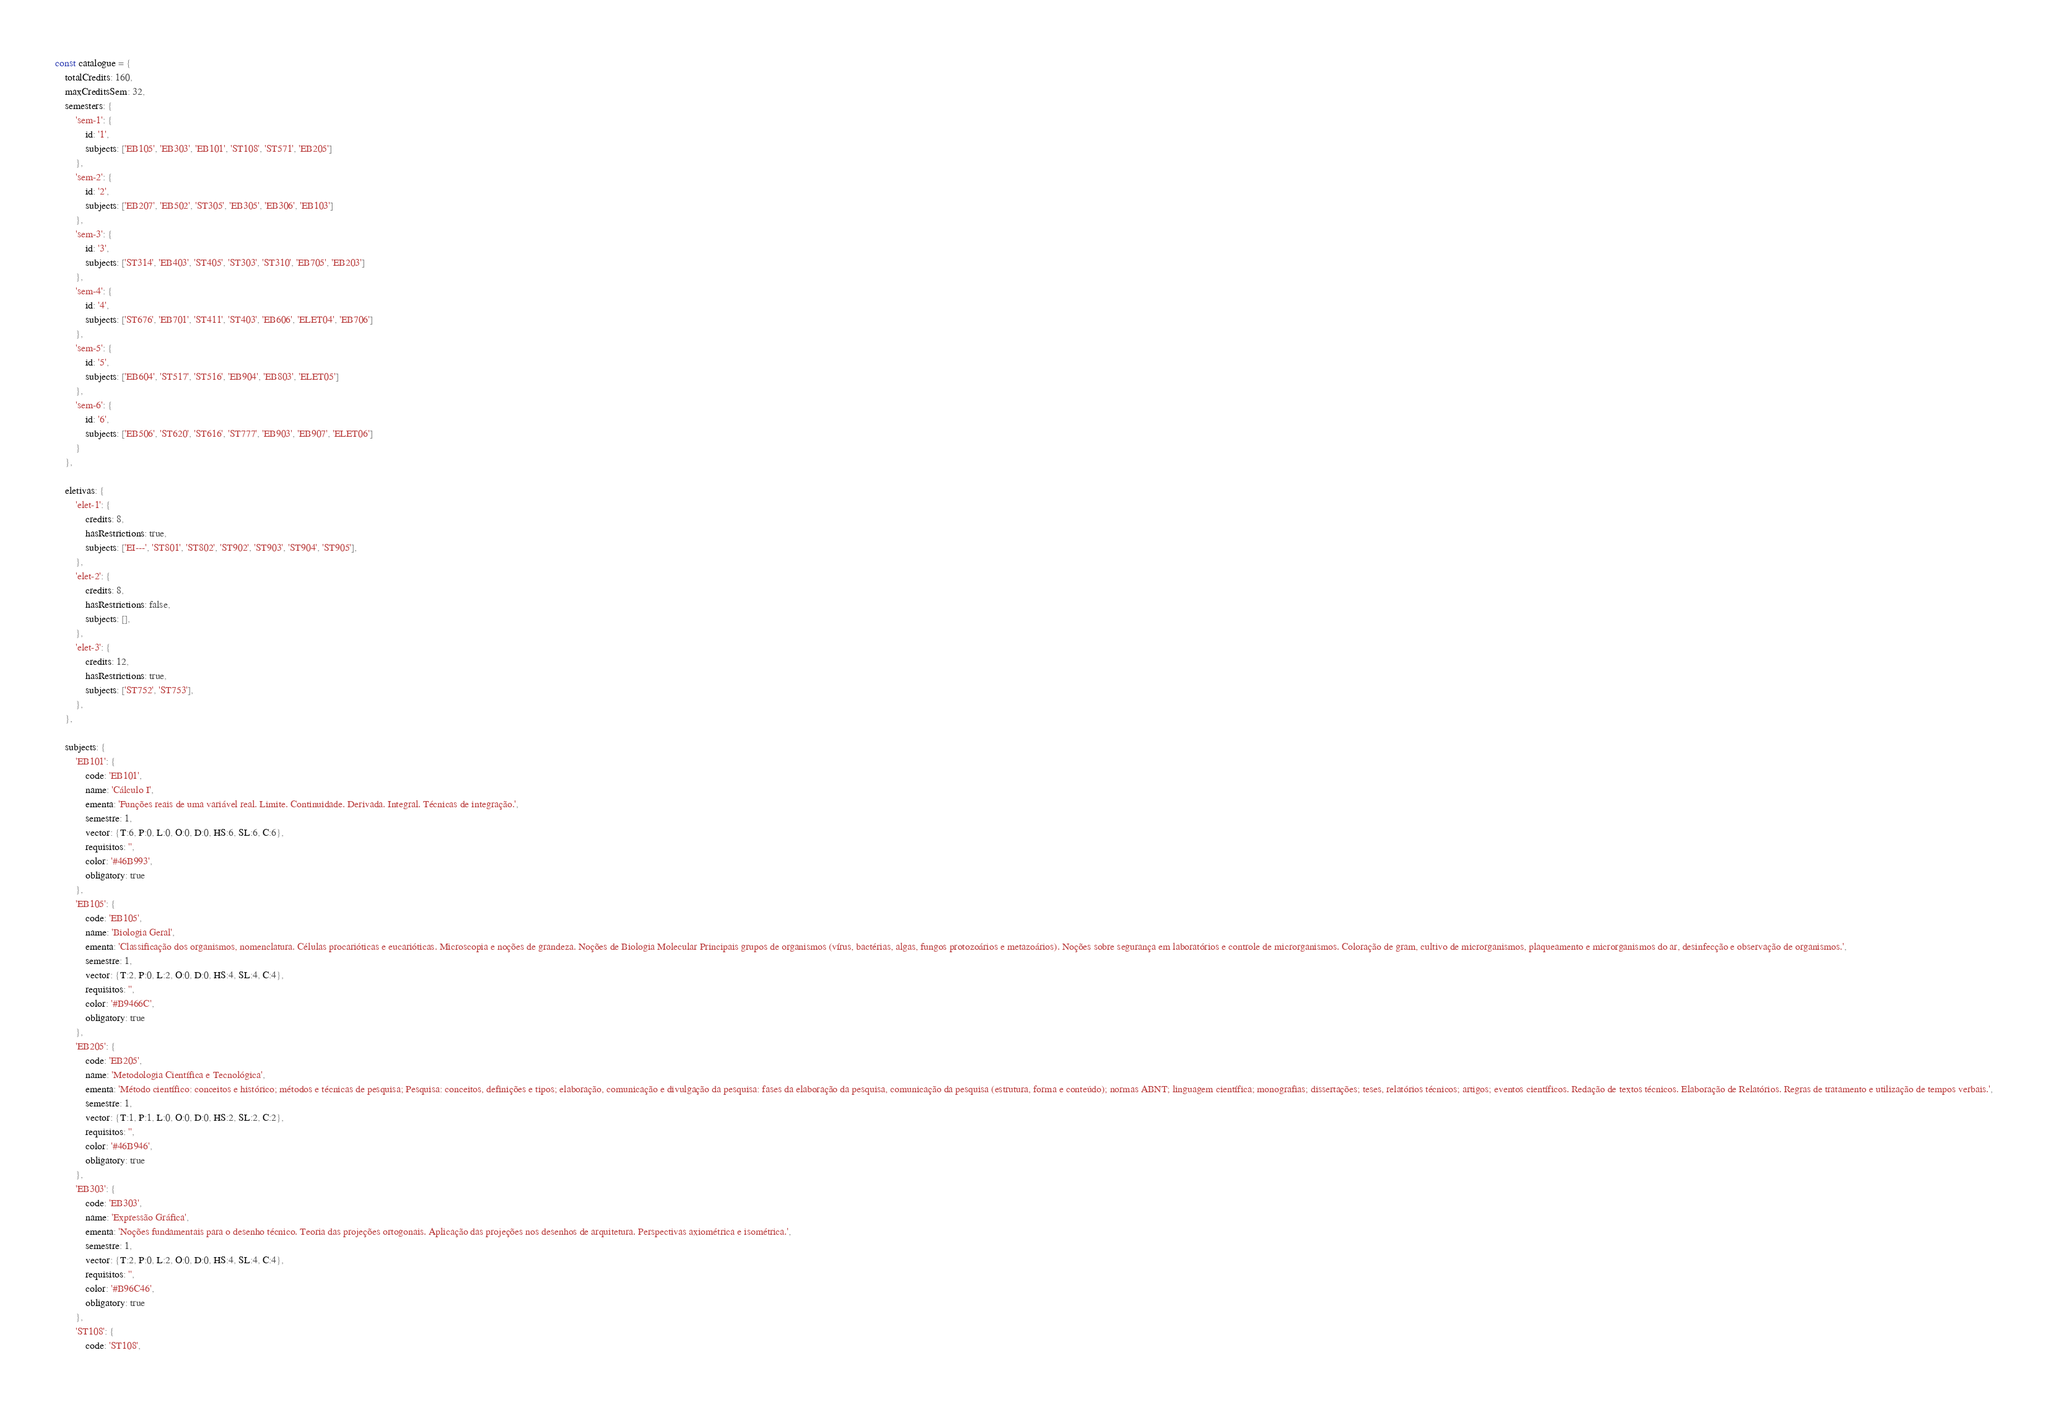Convert code to text. <code><loc_0><loc_0><loc_500><loc_500><_JavaScript_>const catalogue = {
	totalCredits: 160,
	maxCreditsSem: 32,
	semesters: {
		'sem-1': {
			id: '1',
			subjects: ['EB105', 'EB303', 'EB101', 'ST108', 'ST571', 'EB205']
		},
		'sem-2': {
			id: '2',
			subjects: ['EB207', 'EB502', 'ST305', 'EB305', 'EB306', 'EB103']
		},
		'sem-3': {
			id: '3',
			subjects: ['ST314', 'EB403', 'ST405', 'ST303', 'ST310', 'EB705', 'EB203']
		},
		'sem-4': {
			id: '4',
			subjects: ['ST676', 'EB701', 'ST411', 'ST403', 'EB606', 'ELET04', 'EB706']
		},
		'sem-5': {
			id: '5',
			subjects: ['EB604', 'ST517', 'ST516', 'EB904', 'EB803', 'ELET05']
		},
		'sem-6': {
			id: '6',
			subjects: ['EB506', 'ST620', 'ST616', 'ST777', 'EB903', 'EB907', 'ELET06']
		}
	},

	eletivas: {
		'elet-1': {
			credits: 8,
			hasRestrictions: true,
			subjects: ['EI---', 'ST801', 'ST802', 'ST902', 'ST903', 'ST904', 'ST905'],
		},
		'elet-2': {
			credits: 8,
			hasRestrictions: false,
			subjects: [],
		},
		'elet-3': {
			credits: 12,
			hasRestrictions: true,
			subjects: ['ST752', 'ST753'],
		},
	},

	subjects: {
		'EB101': {
			code: 'EB101',
			name: 'Cálculo I',
			ementa: 'Funções reais de uma variável real. Limite. Continuidade. Derivada. Integral. Técnicas de integração.',
			semestre: 1,
			vector: {T:6, P:0, L:0, O:0, D:0, HS:6, SL:6, C:6},
			requisitos: '',
			color: '#46B993',
			obligatory: true
		},
		'EB105': {
			code: 'EB105',
			name: 'Biologia Geral',
			ementa: 'Classificação dos organismos, nomenclatura. Células procarióticas e eucarióticas. Microscopia e noções de grandeza. Noções de Biologia Molecular Principais grupos de organismos (vírus, bactérias, algas, fungos protozoários e metazoários). Noções sobre segurança em laboratórios e controle de microrganismos. Coloração de gram, cultivo de microrganismos, plaqueamento e microrganismos do ar, desinfecção e observação de organismos.',
			semestre: 1,
			vector: {T:2, P:0, L:2, O:0, D:0, HS:4, SL:4, C:4},
			requisitos: '',
			color: '#B9466C',
			obligatory: true
		},
		'EB205': {
			code: 'EB205',
			name: 'Metodologia Científica e Tecnológica',
			ementa: 'Método científico: conceitos e histórico; métodos e técnicas de pesquisa; Pesquisa: conceitos, definições e tipos; elaboração, comunicação e divulgação da pesquisa: fases da elaboração da pesquisa, comunicação da pesquisa (estrutura, forma e conteúdo); normas ABNT; linguagem científica; monografias; dissertações; teses, relatórios técnicos; artigos; eventos científicos. Redação de textos técnicos. Elaboração de Relatórios. Regras de tratamento e utilização de tempos verbais.',
			semestre: 1,
			vector: {T:1, P:1, L:0, O:0, D:0, HS:2, SL:2, C:2},
			requisitos: '',
			color: '#46B946',
			obligatory: true
		},
		'EB303': {
			code: 'EB303',
			name: 'Expressão Gráfica',
			ementa: 'Noções fundamentais para o desenho técnico. Teoria das projeções ortogonais. Aplicação das projeções nos desenhos de arquitetura. Perspectivas axiométrica e isométrica.',
			semestre: 1,
			vector: {T:2, P:0, L:2, O:0, D:0, HS:4, SL:4, C:4},
			requisitos: '',
			color: '#B96C46',
			obligatory: true
		},
		'ST108': {
			code: 'ST108',</code> 